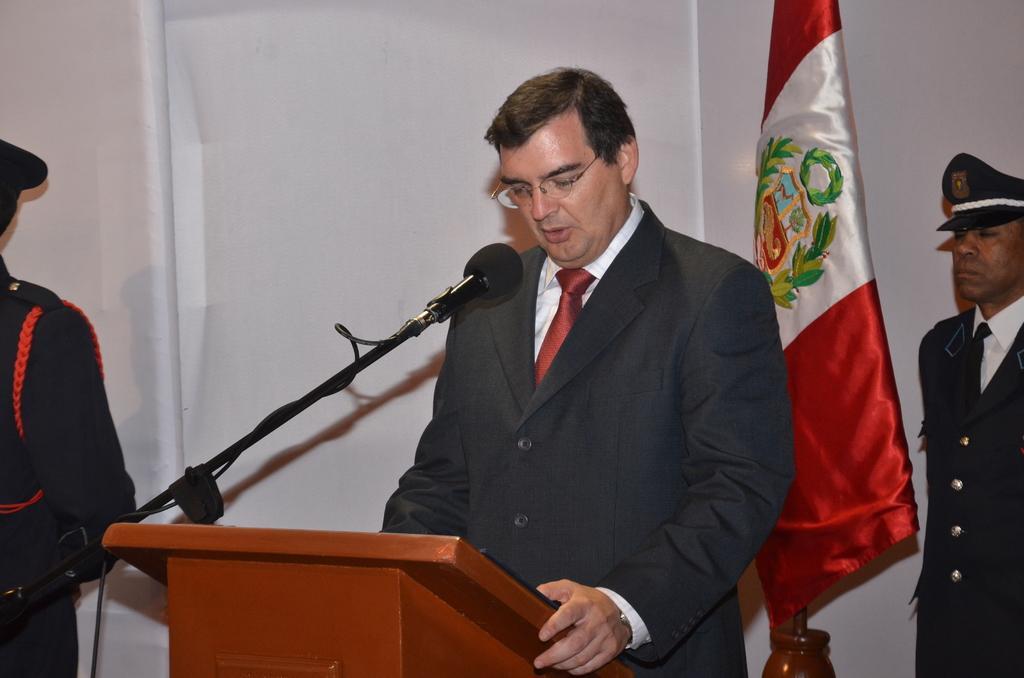Could you give a brief overview of what you see in this image? In this picture we can see a man wearing black color suits, standing at the speech desk and giving a speech. Behind there are two bodyguards wearing black suit and white and red color flag. In the background there is a white banner. 